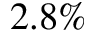Convert formula to latex. <formula><loc_0><loc_0><loc_500><loc_500>2 . 8 \%</formula> 